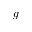<formula> <loc_0><loc_0><loc_500><loc_500>g</formula> 